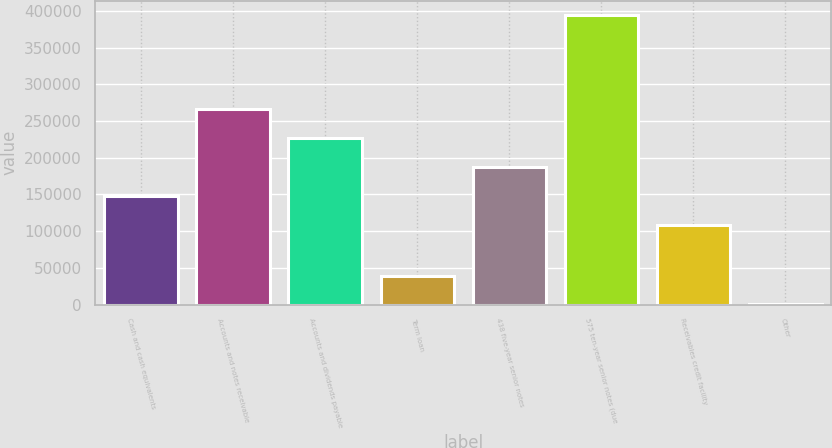Convert chart. <chart><loc_0><loc_0><loc_500><loc_500><bar_chart><fcel>Cash and cash equivalents<fcel>Accounts and notes receivable<fcel>Accounts and dividends payable<fcel>Term loan<fcel>438 five-year senior notes<fcel>575 ten-year senior notes (due<fcel>Receivables credit facility<fcel>Other<nl><fcel>148406<fcel>266622<fcel>227217<fcel>39521.6<fcel>187811<fcel>394172<fcel>109000<fcel>116<nl></chart> 